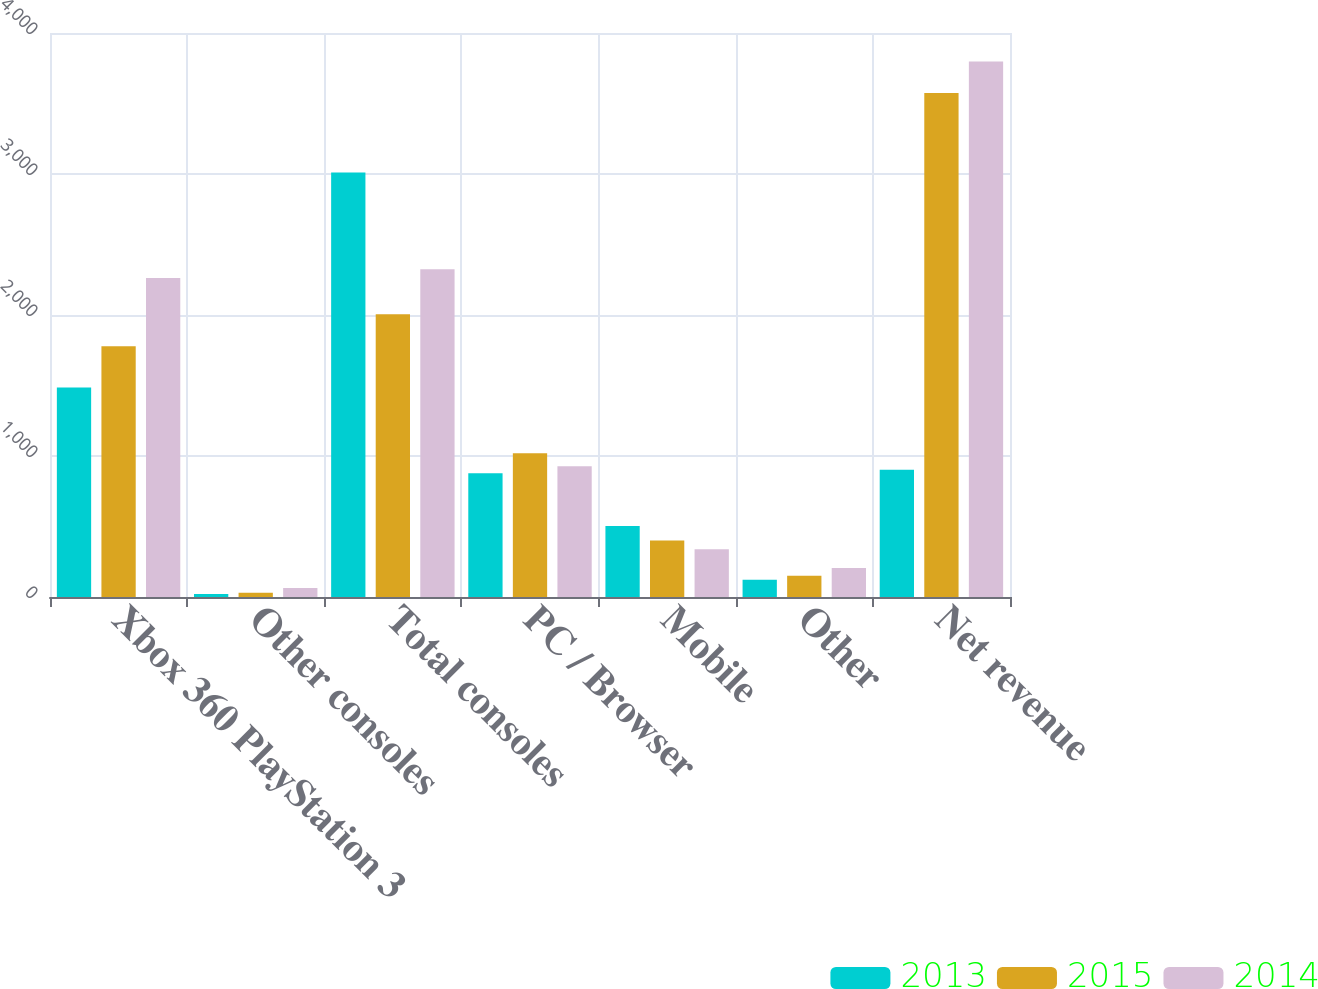Convert chart. <chart><loc_0><loc_0><loc_500><loc_500><stacked_bar_chart><ecel><fcel>Xbox 360 PlayStation 3<fcel>Other consoles<fcel>Total consoles<fcel>PC / Browser<fcel>Mobile<fcel>Other<fcel>Net revenue<nl><fcel>2013<fcel>1485<fcel>21<fcel>3011<fcel>878<fcel>504<fcel>122<fcel>903<nl><fcel>2015<fcel>1779<fcel>30<fcel>2005<fcel>1020<fcel>400<fcel>150<fcel>3575<nl><fcel>2014<fcel>2262<fcel>63<fcel>2325<fcel>928<fcel>339<fcel>205<fcel>3797<nl></chart> 